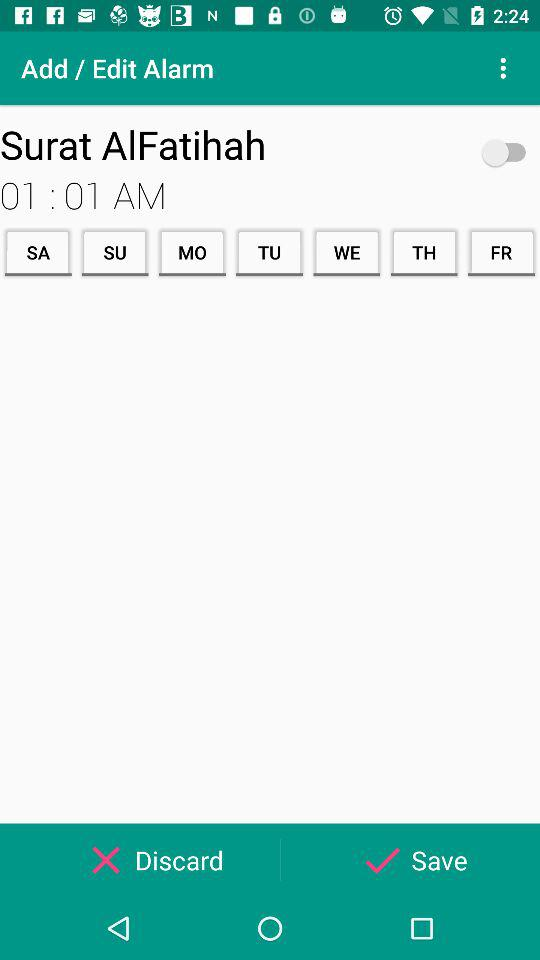What is the status of the alarm "Surat AlFatihah"? The status of the alarm "Surat AlFatihah" is "off". 